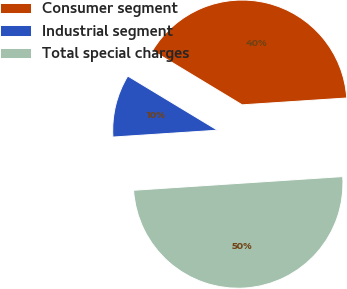Convert chart to OTSL. <chart><loc_0><loc_0><loc_500><loc_500><pie_chart><fcel>Consumer segment<fcel>Industrial segment<fcel>Total special charges<nl><fcel>40.31%<fcel>9.69%<fcel>50.0%<nl></chart> 